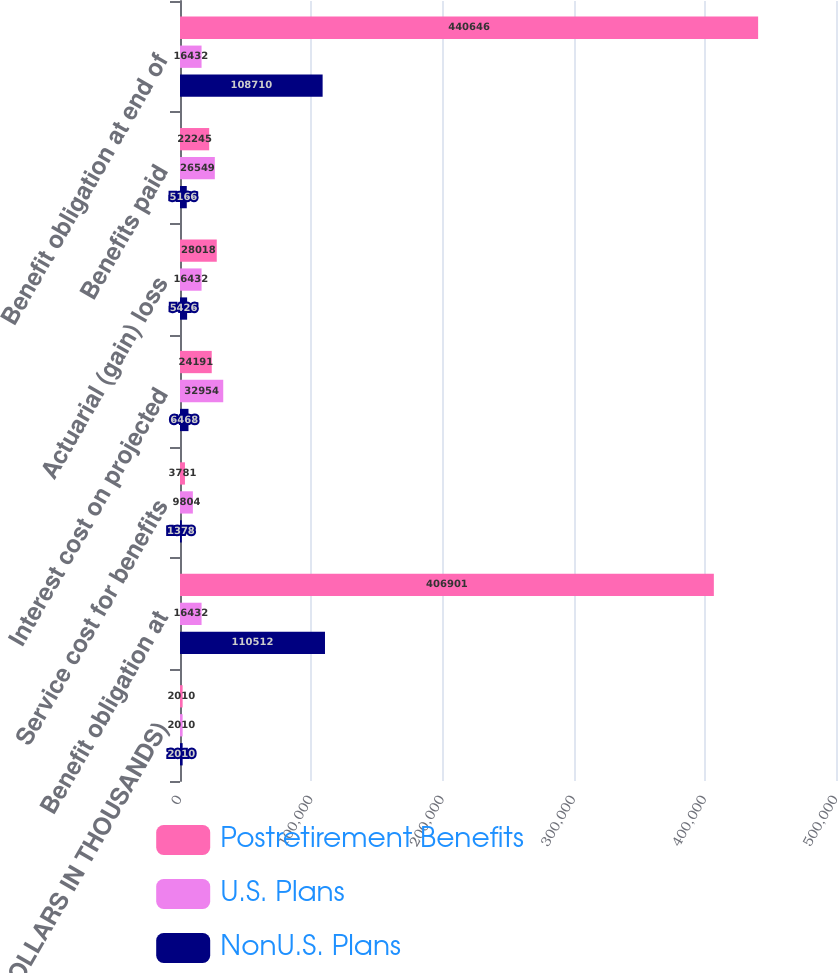Convert chart. <chart><loc_0><loc_0><loc_500><loc_500><stacked_bar_chart><ecel><fcel>(DOLLARS IN THOUSANDS)<fcel>Benefit obligation at<fcel>Service cost for benefits<fcel>Interest cost on projected<fcel>Actuarial (gain) loss<fcel>Benefits paid<fcel>Benefit obligation at end of<nl><fcel>Postretirement Benefits<fcel>2010<fcel>406901<fcel>3781<fcel>24191<fcel>28018<fcel>22245<fcel>440646<nl><fcel>U.S. Plans<fcel>2010<fcel>16432<fcel>9804<fcel>32954<fcel>16432<fcel>26549<fcel>16432<nl><fcel>NonU.S. Plans<fcel>2010<fcel>110512<fcel>1378<fcel>6468<fcel>5426<fcel>5166<fcel>108710<nl></chart> 